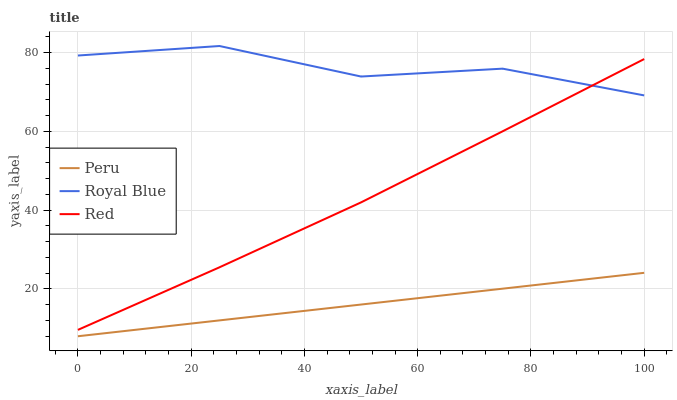Does Peru have the minimum area under the curve?
Answer yes or no. Yes. Does Royal Blue have the maximum area under the curve?
Answer yes or no. Yes. Does Red have the minimum area under the curve?
Answer yes or no. No. Does Red have the maximum area under the curve?
Answer yes or no. No. Is Peru the smoothest?
Answer yes or no. Yes. Is Royal Blue the roughest?
Answer yes or no. Yes. Is Red the smoothest?
Answer yes or no. No. Is Red the roughest?
Answer yes or no. No. Does Peru have the lowest value?
Answer yes or no. Yes. Does Red have the lowest value?
Answer yes or no. No. Does Royal Blue have the highest value?
Answer yes or no. Yes. Does Red have the highest value?
Answer yes or no. No. Is Peru less than Red?
Answer yes or no. Yes. Is Red greater than Peru?
Answer yes or no. Yes. Does Red intersect Royal Blue?
Answer yes or no. Yes. Is Red less than Royal Blue?
Answer yes or no. No. Is Red greater than Royal Blue?
Answer yes or no. No. Does Peru intersect Red?
Answer yes or no. No. 